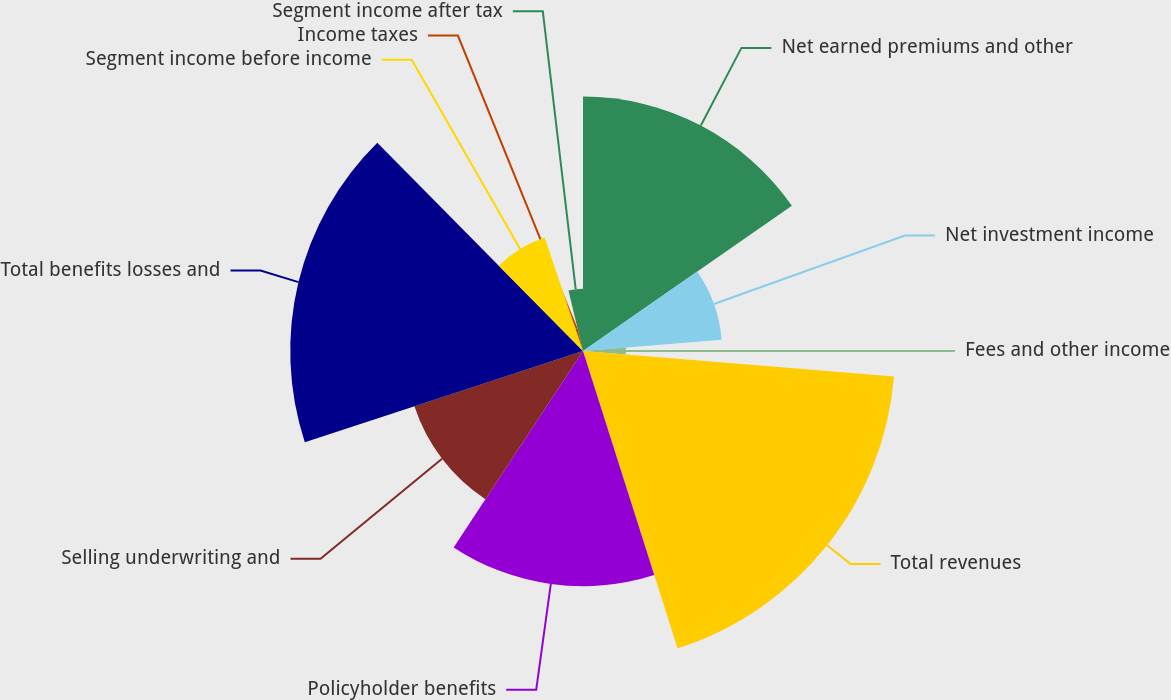Convert chart to OTSL. <chart><loc_0><loc_0><loc_500><loc_500><pie_chart><fcel>Net earned premiums and other<fcel>Net investment income<fcel>Fees and other income<fcel>Total revenues<fcel>Policyholder benefits<fcel>Selling underwriting and<fcel>Total benefits losses and<fcel>Segment income before income<fcel>Income taxes<fcel>Segment income after tax<nl><fcel>15.33%<fcel>8.38%<fcel>2.59%<fcel>18.8%<fcel>14.17%<fcel>10.69%<fcel>17.64%<fcel>7.22%<fcel>1.43%<fcel>3.75%<nl></chart> 